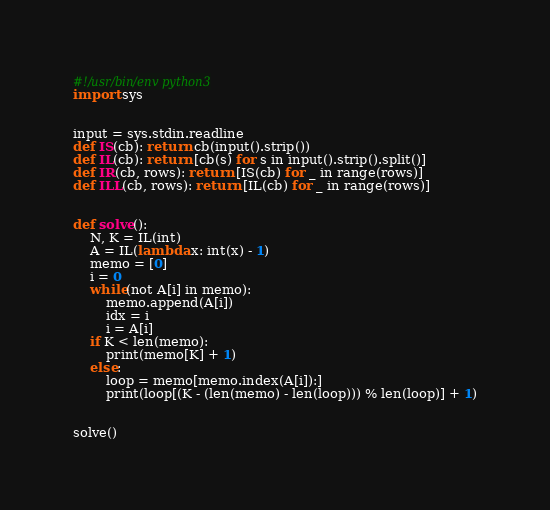Convert code to text. <code><loc_0><loc_0><loc_500><loc_500><_Python_>#!/usr/bin/env python3
import sys


input = sys.stdin.readline
def IS(cb): return cb(input().strip())
def IL(cb): return [cb(s) for s in input().strip().split()]
def IR(cb, rows): return [IS(cb) for _ in range(rows)]
def ILL(cb, rows): return [IL(cb) for _ in range(rows)]


def solve():
    N, K = IL(int)
    A = IL(lambda x: int(x) - 1)
    memo = [0]
    i = 0
    while(not A[i] in memo):
        memo.append(A[i])
        idx = i
        i = A[i]
    if K < len(memo):
        print(memo[K] + 1)
    else:
        loop = memo[memo.index(A[i]):]
        print(loop[(K - (len(memo) - len(loop))) % len(loop)] + 1)


solve()
</code> 